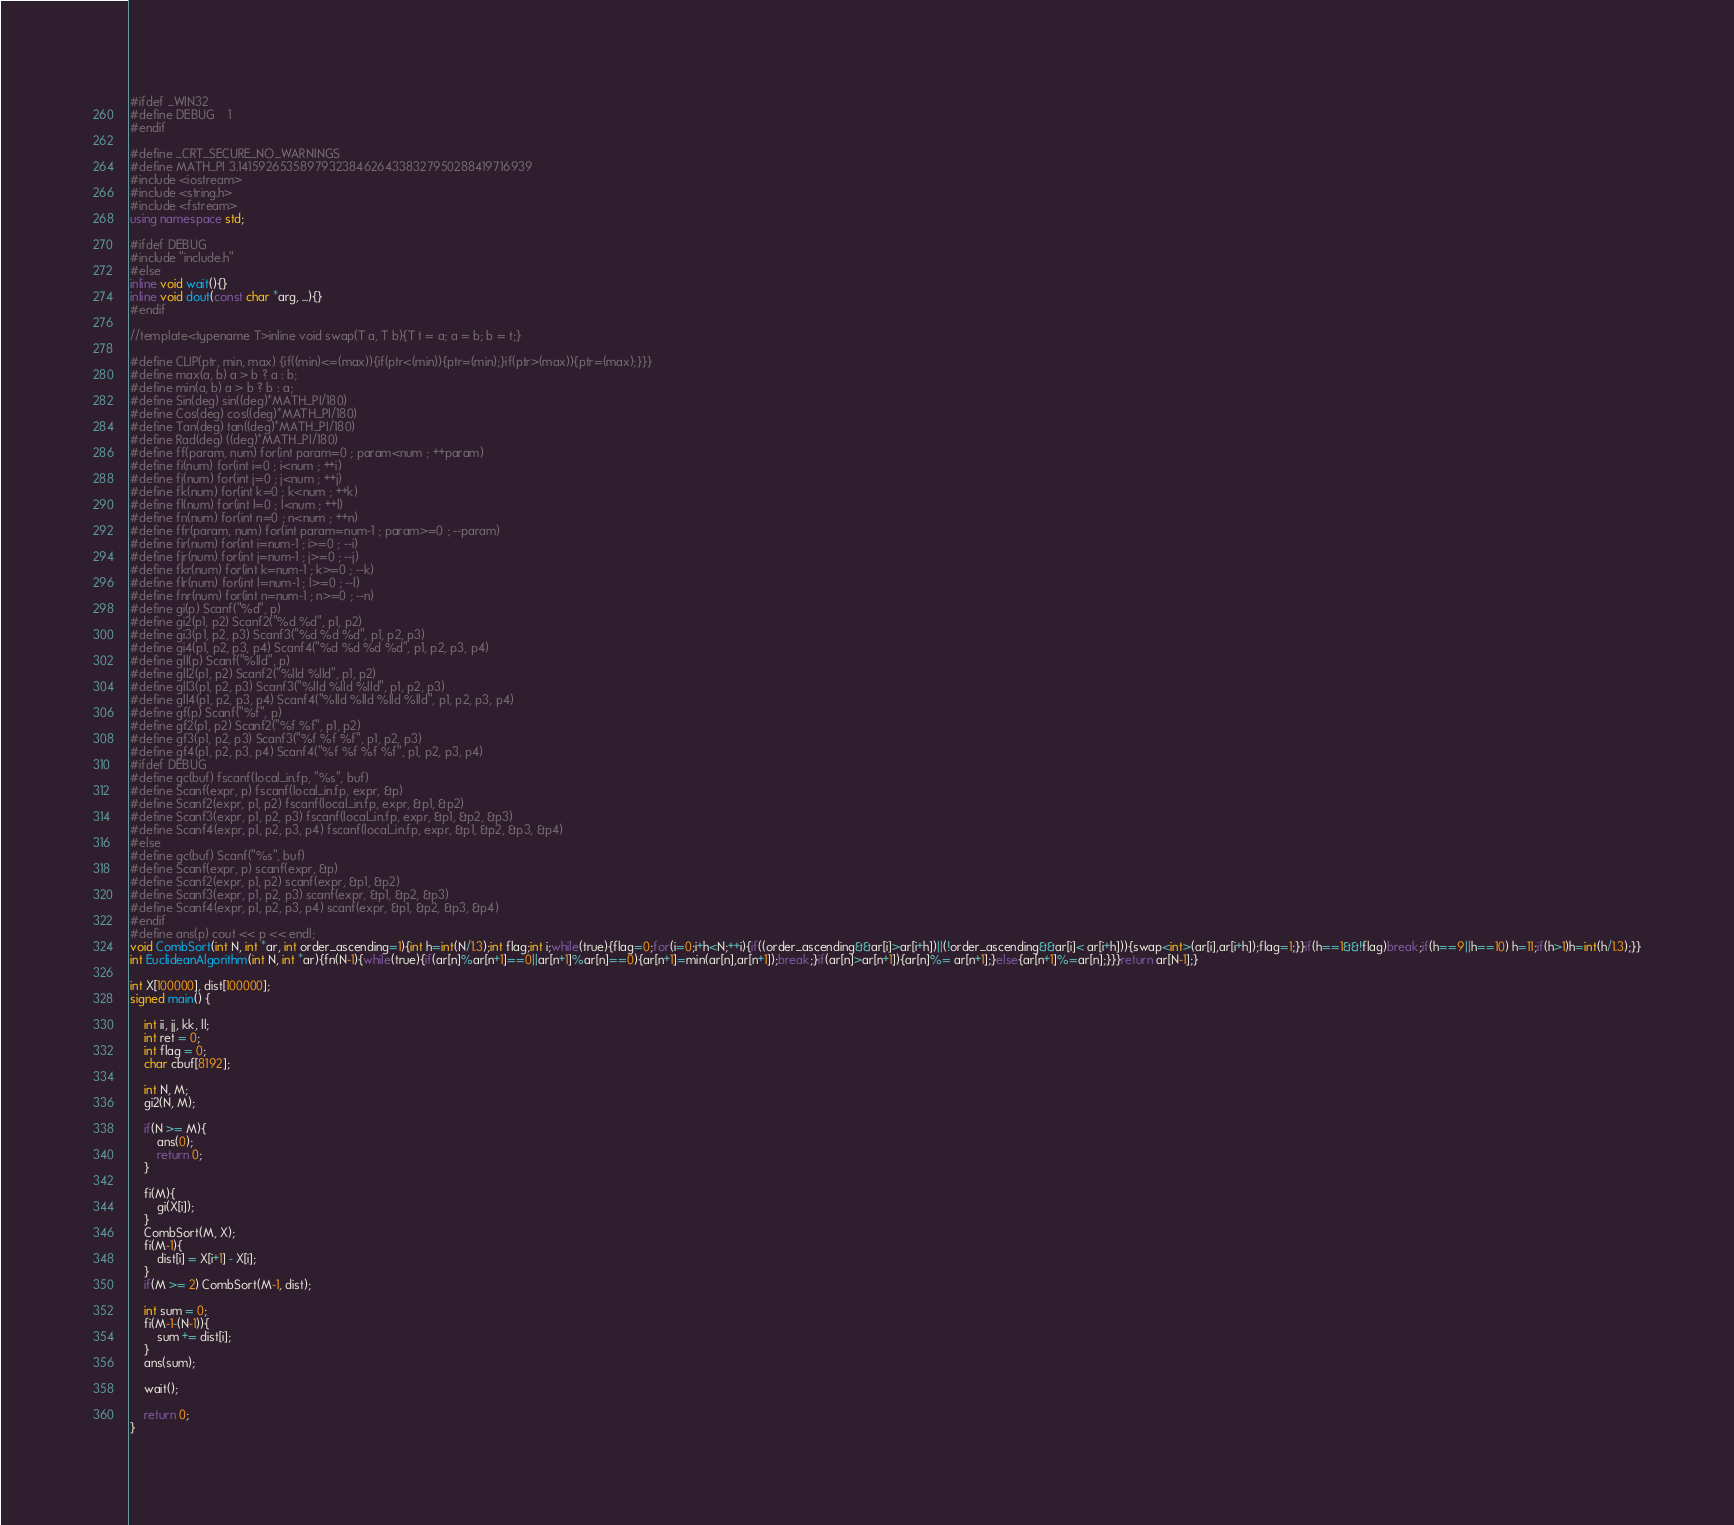Convert code to text. <code><loc_0><loc_0><loc_500><loc_500><_C++_>#ifdef _WIN32
#define DEBUG	1
#endif

#define _CRT_SECURE_NO_WARNINGS
#define MATH_PI 3.14159265358979323846264338327950288419716939
#include <iostream>
#include <string.h>
#include <fstream>
using namespace std;

#ifdef DEBUG
#include "include.h"
#else
inline void wait(){}
inline void dout(const char *arg, ...){}
#endif

//template<typename T>inline void swap(T a, T b){T t = a; a = b; b = t;}

#define CLIP(ptr, min, max) {if((min)<=(max)){if(ptr<(min)){ptr=(min);}if(ptr>(max)){ptr=(max);}}}
#define max(a, b) a > b ? a : b;
#define min(a, b) a > b ? b : a;
#define Sin(deg) sin((deg)*MATH_PI/180)
#define Cos(deg) cos((deg)*MATH_PI/180)
#define Tan(deg) tan((deg)*MATH_PI/180)
#define Rad(deg) ((deg)*MATH_PI/180)
#define ff(param, num) for(int param=0 ; param<num ; ++param)
#define fi(num) for(int i=0 ; i<num ; ++i)
#define fj(num) for(int j=0 ; j<num ; ++j)
#define fk(num) for(int k=0 ; k<num ; ++k)
#define fl(num) for(int l=0 ; l<num ; ++l)
#define fn(num) for(int n=0 ; n<num ; ++n)
#define ffr(param, num) for(int param=num-1 ; param>=0 ; --param)
#define fir(num) for(int i=num-1 ; i>=0 ; --i)
#define fjr(num) for(int j=num-1 ; j>=0 ; --j)
#define fkr(num) for(int k=num-1 ; k>=0 ; --k)
#define flr(num) for(int l=num-1 ; l>=0 ; --l)
#define fnr(num) for(int n=num-1 ; n>=0 ; --n)
#define gi(p) Scanf("%d", p)
#define gi2(p1, p2) Scanf2("%d %d", p1, p2)
#define gi3(p1, p2, p3) Scanf3("%d %d %d", p1, p2, p3)
#define gi4(p1, p2, p3, p4) Scanf4("%d %d %d %d", p1, p2, p3, p4)
#define gll(p) Scanf("%lld", p)
#define gll2(p1, p2) Scanf2("%lld %lld", p1, p2)
#define gll3(p1, p2, p3) Scanf3("%lld %lld %lld", p1, p2, p3)
#define gll4(p1, p2, p3, p4) Scanf4("%lld %lld %lld %lld", p1, p2, p3, p4)
#define gf(p) Scanf("%f", p)
#define gf2(p1, p2) Scanf2("%f %f", p1, p2)
#define gf3(p1, p2, p3) Scanf3("%f %f %f", p1, p2, p3)
#define gf4(p1, p2, p3, p4) Scanf4("%f %f %f %f", p1, p2, p3, p4)
#ifdef DEBUG
#define gc(buf) fscanf(local_in.fp, "%s", buf)
#define Scanf(expr, p) fscanf(local_in.fp, expr, &p)
#define Scanf2(expr, p1, p2) fscanf(local_in.fp, expr, &p1, &p2)
#define Scanf3(expr, p1, p2, p3) fscanf(local_in.fp, expr, &p1, &p2, &p3)
#define Scanf4(expr, p1, p2, p3, p4) fscanf(local_in.fp, expr, &p1, &p2, &p3, &p4)
#else
#define gc(buf) Scanf("%s", buf)
#define Scanf(expr, p) scanf(expr, &p)
#define Scanf2(expr, p1, p2) scanf(expr, &p1, &p2)
#define Scanf3(expr, p1, p2, p3) scanf(expr, &p1, &p2, &p3)
#define Scanf4(expr, p1, p2, p3, p4) scanf(expr, &p1, &p2, &p3, &p4)
#endif
#define ans(p) cout << p << endl;
void CombSort(int N, int *ar, int order_ascending=1){int h=int(N/1.3);int flag;int i;while(true){flag=0;for(i=0;i+h<N;++i){if((order_ascending&&ar[i]>ar[i+h])||(!order_ascending&&ar[i]< ar[i+h])){swap<int>(ar[i],ar[i+h]);flag=1;}}if(h==1&&!flag)break;if(h==9||h==10) h=11;if(h>1)h=int(h/1.3);}}
int EuclideanAlgorithm(int N, int *ar){fn(N-1){while(true){if(ar[n]%ar[n+1]==0||ar[n+1]%ar[n]==0){ar[n+1]=min(ar[n],ar[n+1]);break;}if(ar[n]>ar[n+1]){ar[n]%= ar[n+1];}else{ar[n+1]%=ar[n];}}}return ar[N-1];}

int X[100000], dist[100000];
signed main() {

	int ii, jj, kk, ll;
	int ret = 0;
	int flag = 0;
	char cbuf[8192];

	int N, M;
	gi2(N, M);

	if(N >= M){
		ans(0);
		return 0;
	}

	fi(M){
		gi(X[i]);
	}
	CombSort(M, X);
	fi(M-1){
		dist[i] = X[i+1] - X[i];
	}
	if(M >= 2) CombSort(M-1, dist);

	int sum = 0;
	fi(M-1-(N-1)){
		sum += dist[i];
	}
	ans(sum);

	wait();

	return 0;
}</code> 